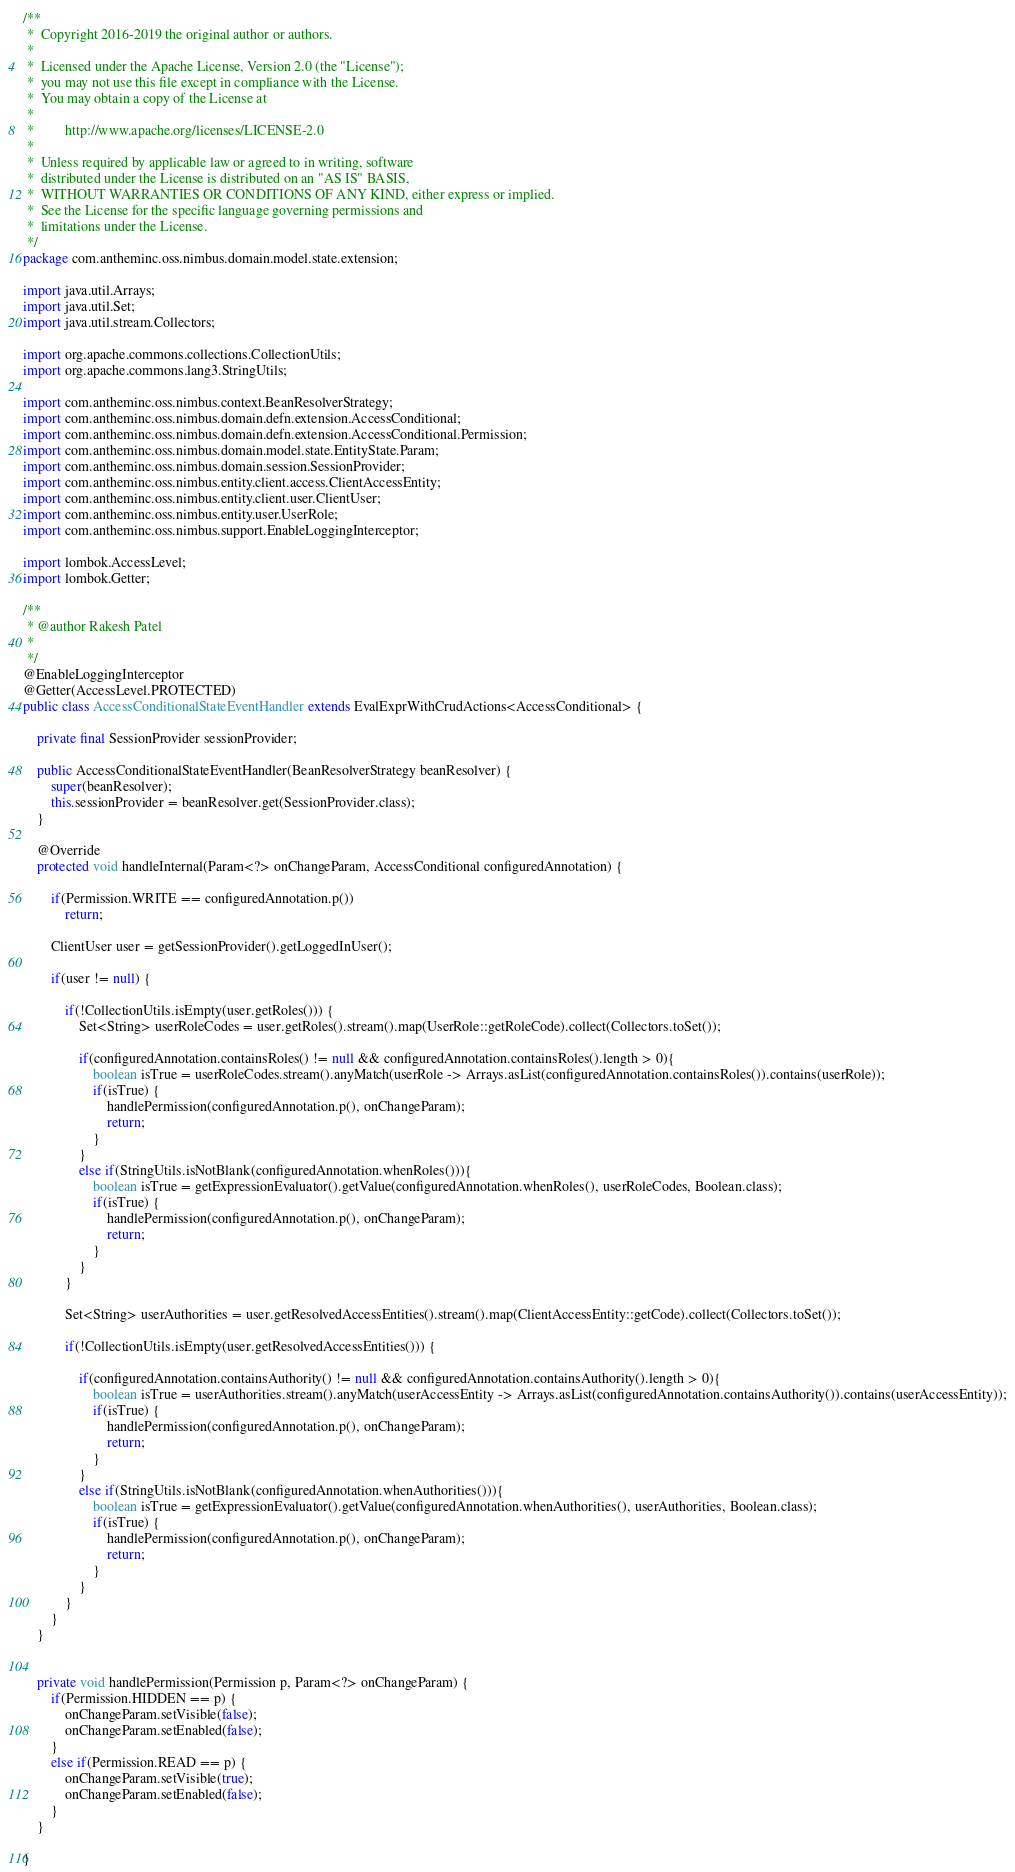<code> <loc_0><loc_0><loc_500><loc_500><_Java_>/**
 *  Copyright 2016-2019 the original author or authors.
 *
 *  Licensed under the Apache License, Version 2.0 (the "License");
 *  you may not use this file except in compliance with the License.
 *  You may obtain a copy of the License at
 *
 *         http://www.apache.org/licenses/LICENSE-2.0
 *
 *  Unless required by applicable law or agreed to in writing, software
 *  distributed under the License is distributed on an "AS IS" BASIS,
 *  WITHOUT WARRANTIES OR CONDITIONS OF ANY KIND, either express or implied.
 *  See the License for the specific language governing permissions and
 *  limitations under the License.
 */
package com.antheminc.oss.nimbus.domain.model.state.extension;

import java.util.Arrays;
import java.util.Set;
import java.util.stream.Collectors;

import org.apache.commons.collections.CollectionUtils;
import org.apache.commons.lang3.StringUtils;

import com.antheminc.oss.nimbus.context.BeanResolverStrategy;
import com.antheminc.oss.nimbus.domain.defn.extension.AccessConditional;
import com.antheminc.oss.nimbus.domain.defn.extension.AccessConditional.Permission;
import com.antheminc.oss.nimbus.domain.model.state.EntityState.Param;
import com.antheminc.oss.nimbus.domain.session.SessionProvider;
import com.antheminc.oss.nimbus.entity.client.access.ClientAccessEntity;
import com.antheminc.oss.nimbus.entity.client.user.ClientUser;
import com.antheminc.oss.nimbus.entity.user.UserRole;
import com.antheminc.oss.nimbus.support.EnableLoggingInterceptor;

import lombok.AccessLevel;
import lombok.Getter;

/**
 * @author Rakesh Patel
 *
 */
@EnableLoggingInterceptor
@Getter(AccessLevel.PROTECTED)
public class AccessConditionalStateEventHandler extends EvalExprWithCrudActions<AccessConditional> {
	
	private final SessionProvider sessionProvider;
	
	public AccessConditionalStateEventHandler(BeanResolverStrategy beanResolver) {
		super(beanResolver);
		this.sessionProvider = beanResolver.get(SessionProvider.class);
	}
	
	@Override
	protected void handleInternal(Param<?> onChangeParam, AccessConditional configuredAnnotation) {
		
		if(Permission.WRITE == configuredAnnotation.p())
			return;
		
		ClientUser user = getSessionProvider().getLoggedInUser();
		
		if(user != null) {
			
			if(!CollectionUtils.isEmpty(user.getRoles())) {
				Set<String> userRoleCodes = user.getRoles().stream().map(UserRole::getRoleCode).collect(Collectors.toSet());
				
				if(configuredAnnotation.containsRoles() != null && configuredAnnotation.containsRoles().length > 0){
					boolean isTrue = userRoleCodes.stream().anyMatch(userRole -> Arrays.asList(configuredAnnotation.containsRoles()).contains(userRole));
					if(isTrue) {	
						handlePermission(configuredAnnotation.p(), onChangeParam);
						return;
					}
				}
				else if(StringUtils.isNotBlank(configuredAnnotation.whenRoles())){
					boolean isTrue = getExpressionEvaluator().getValue(configuredAnnotation.whenRoles(), userRoleCodes, Boolean.class);
					if(isTrue) {
						handlePermission(configuredAnnotation.p(), onChangeParam);
						return;
					}
				}
			}
			
			Set<String> userAuthorities = user.getResolvedAccessEntities().stream().map(ClientAccessEntity::getCode).collect(Collectors.toSet());
			
			if(!CollectionUtils.isEmpty(user.getResolvedAccessEntities())) {
			
				if(configuredAnnotation.containsAuthority() != null && configuredAnnotation.containsAuthority().length > 0){
					boolean isTrue = userAuthorities.stream().anyMatch(userAccessEntity -> Arrays.asList(configuredAnnotation.containsAuthority()).contains(userAccessEntity));
					if(isTrue) {
						handlePermission(configuredAnnotation.p(), onChangeParam);
						return;
					}
				}
				else if(StringUtils.isNotBlank(configuredAnnotation.whenAuthorities())){
					boolean isTrue = getExpressionEvaluator().getValue(configuredAnnotation.whenAuthorities(), userAuthorities, Boolean.class);
					if(isTrue) {
						handlePermission(configuredAnnotation.p(), onChangeParam);
						return;
					}
				}
			}
		}
	}
	
	
	private void handlePermission(Permission p, Param<?> onChangeParam) {
		if(Permission.HIDDEN == p) {
			onChangeParam.setVisible(false);
			onChangeParam.setEnabled(false);
		}
		else if(Permission.READ == p) {
			onChangeParam.setVisible(true);
			onChangeParam.setEnabled(false);
		}
	}
		
}
</code> 